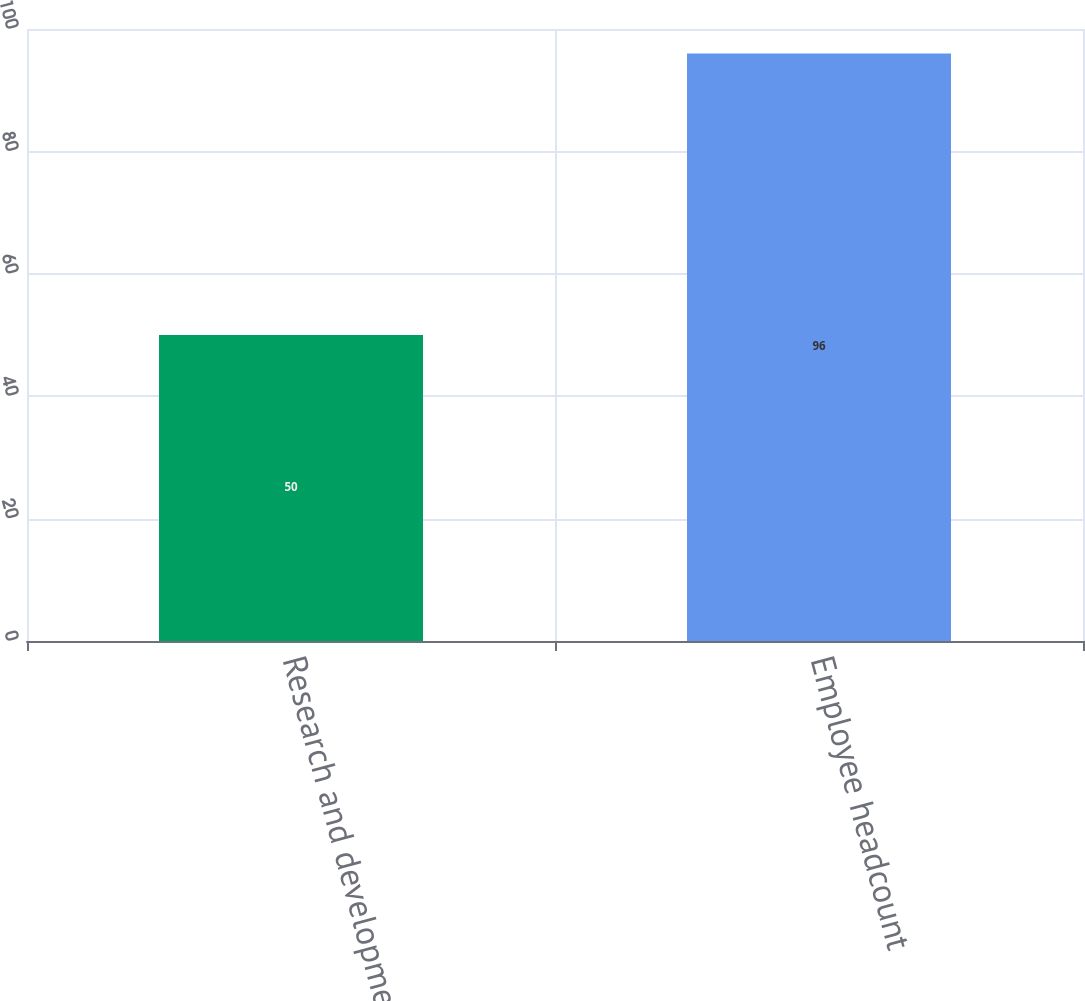Convert chart. <chart><loc_0><loc_0><loc_500><loc_500><bar_chart><fcel>Research and development<fcel>Employee headcount<nl><fcel>50<fcel>96<nl></chart> 